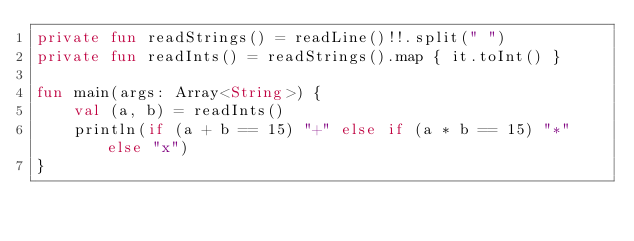<code> <loc_0><loc_0><loc_500><loc_500><_Kotlin_>private fun readStrings() = readLine()!!.split(" ")
private fun readInts() = readStrings().map { it.toInt() }

fun main(args: Array<String>) {
    val (a, b) = readInts()
    println(if (a + b == 15) "+" else if (a * b == 15) "*" else "x")
}</code> 